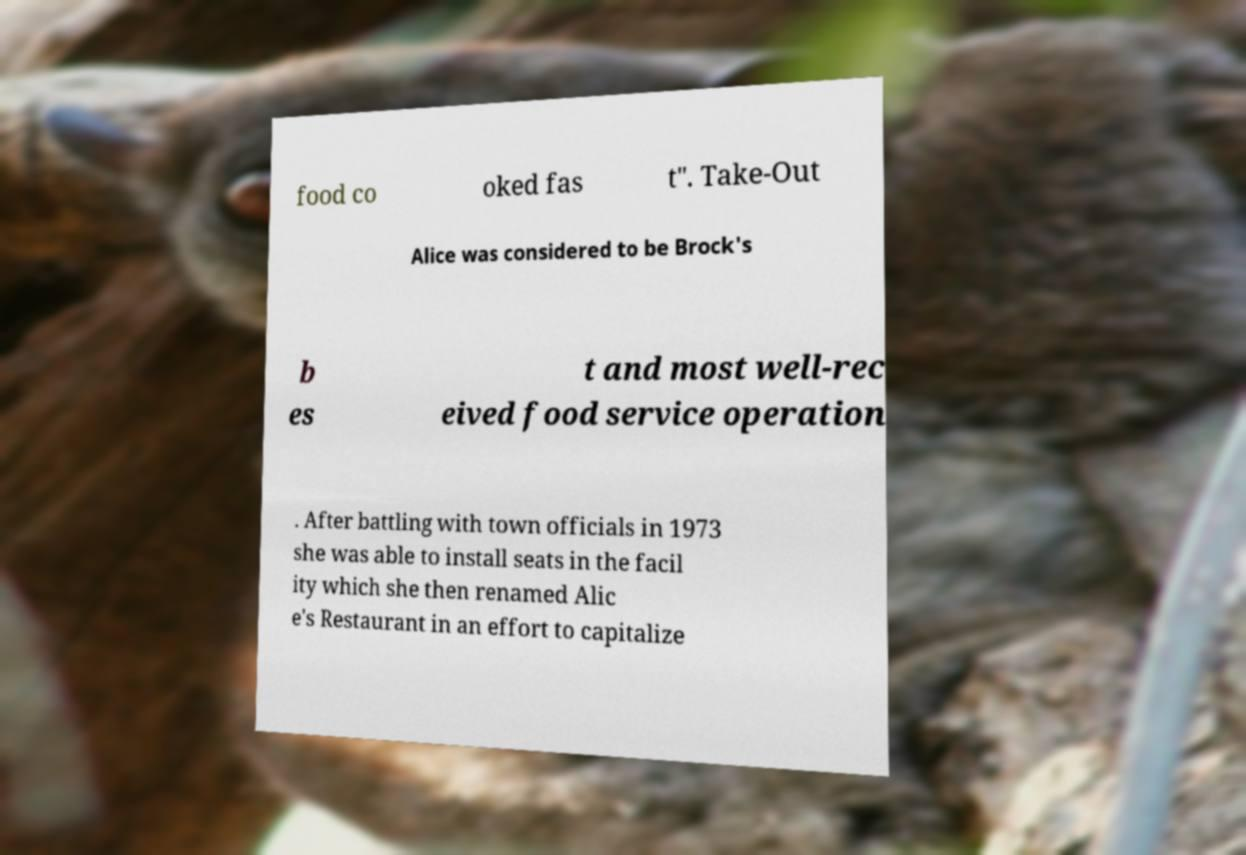For documentation purposes, I need the text within this image transcribed. Could you provide that? food co oked fas t". Take-Out Alice was considered to be Brock's b es t and most well-rec eived food service operation . After battling with town officials in 1973 she was able to install seats in the facil ity which she then renamed Alic e's Restaurant in an effort to capitalize 